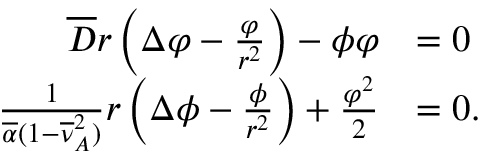<formula> <loc_0><loc_0><loc_500><loc_500>\begin{array} { r l } { \overline { D } r \left ( \Delta \varphi - \frac { \varphi } { r ^ { 2 } } \right ) - \phi \varphi } & { = 0 } \\ { \frac { 1 } { \overline { \alpha } ( 1 - \overline { \nu } _ { A } ^ { 2 } ) } r \left ( \Delta \phi - \frac { \phi } { r ^ { 2 } } \right ) + \frac { \varphi ^ { 2 } } { 2 } } & { = 0 . } \end{array}</formula> 